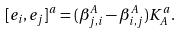<formula> <loc_0><loc_0><loc_500><loc_500>[ e _ { i } , e _ { j } ] ^ { a } = ( \beta ^ { A } _ { j , i } - \beta ^ { A } _ { i , j } ) K _ { A } ^ { a } .</formula> 